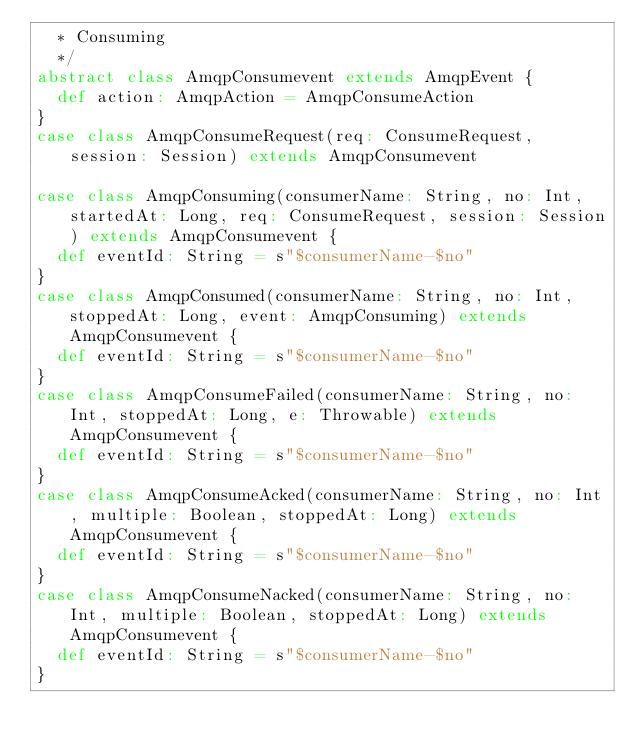<code> <loc_0><loc_0><loc_500><loc_500><_Scala_>  * Consuming
  */
abstract class AmqpConsumevent extends AmqpEvent {
  def action: AmqpAction = AmqpConsumeAction
}
case class AmqpConsumeRequest(req: ConsumeRequest, session: Session) extends AmqpConsumevent

case class AmqpConsuming(consumerName: String, no: Int, startedAt: Long, req: ConsumeRequest, session: Session) extends AmqpConsumevent {
  def eventId: String = s"$consumerName-$no"
}
case class AmqpConsumed(consumerName: String, no: Int, stoppedAt: Long, event: AmqpConsuming) extends AmqpConsumevent {
  def eventId: String = s"$consumerName-$no"
}
case class AmqpConsumeFailed(consumerName: String, no: Int, stoppedAt: Long, e: Throwable) extends AmqpConsumevent {
  def eventId: String = s"$consumerName-$no"
}
case class AmqpConsumeAcked(consumerName: String, no: Int, multiple: Boolean, stoppedAt: Long) extends AmqpConsumevent {
  def eventId: String = s"$consumerName-$no"
}
case class AmqpConsumeNacked(consumerName: String, no: Int, multiple: Boolean, stoppedAt: Long) extends AmqpConsumevent {
  def eventId: String = s"$consumerName-$no"
}
</code> 